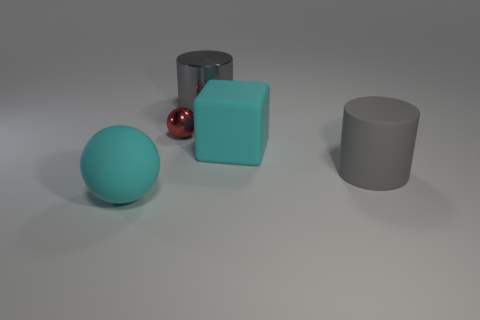Is there any other thing that is the same size as the red thing?
Offer a terse response. No. Does the gray matte object have the same shape as the gray metal thing?
Your answer should be very brief. Yes. What material is the sphere on the right side of the large cyan rubber sphere that is in front of the tiny red thing?
Provide a short and direct response. Metal. There is a ball that is the same color as the block; what material is it?
Your answer should be very brief. Rubber. Do the gray matte cylinder and the gray metallic object have the same size?
Your answer should be compact. Yes. There is a big gray object in front of the large metallic thing; is there a gray cylinder that is left of it?
Offer a very short reply. Yes. The cyan rubber object in front of the gray rubber object has what shape?
Provide a short and direct response. Sphere. How many small red shiny balls are left of the metallic object behind the metallic thing that is left of the large gray shiny cylinder?
Offer a very short reply. 1. There is a red thing; does it have the same size as the cyan object on the right side of the gray shiny cylinder?
Ensure brevity in your answer.  No. What size is the gray cylinder that is behind the cyan object that is on the right side of the tiny red sphere?
Make the answer very short. Large. 